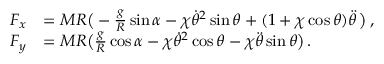Convert formula to latex. <formula><loc_0><loc_0><loc_500><loc_500>\begin{array} { r l } { F _ { x } } & { = M R \left ( - \frac { g } { R } \sin \alpha - \chi \dot { \theta } ^ { 2 } \sin \theta + ( 1 + \chi \cos \theta ) \ddot { \theta } \, \right ) \, , } \\ { F _ { y } } & { = M R \left ( \frac { g } { R } \cos \alpha - \chi \dot { \theta } ^ { 2 } \cos \theta - \chi \ddot { \theta } \sin \theta \right ) \, . } \end{array}</formula> 